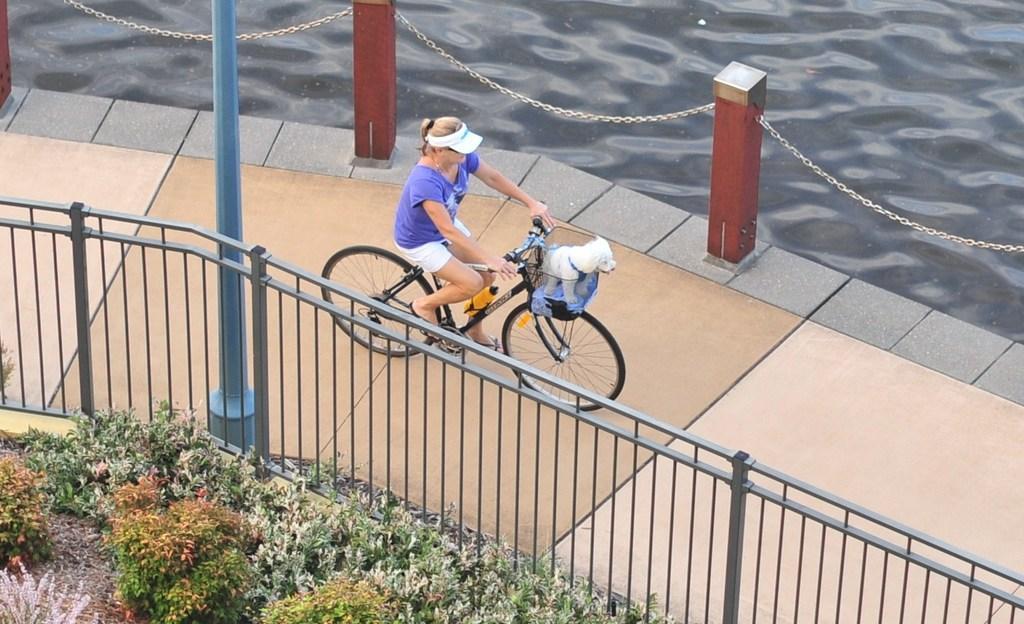Please provide a concise description of this image. this picture shows a woman riding a bicycle on the sidewalk and we see a dog in the basket of the cycle and she wore a cap on her head and we see water on the side and a metal fence and few plants around and pole 